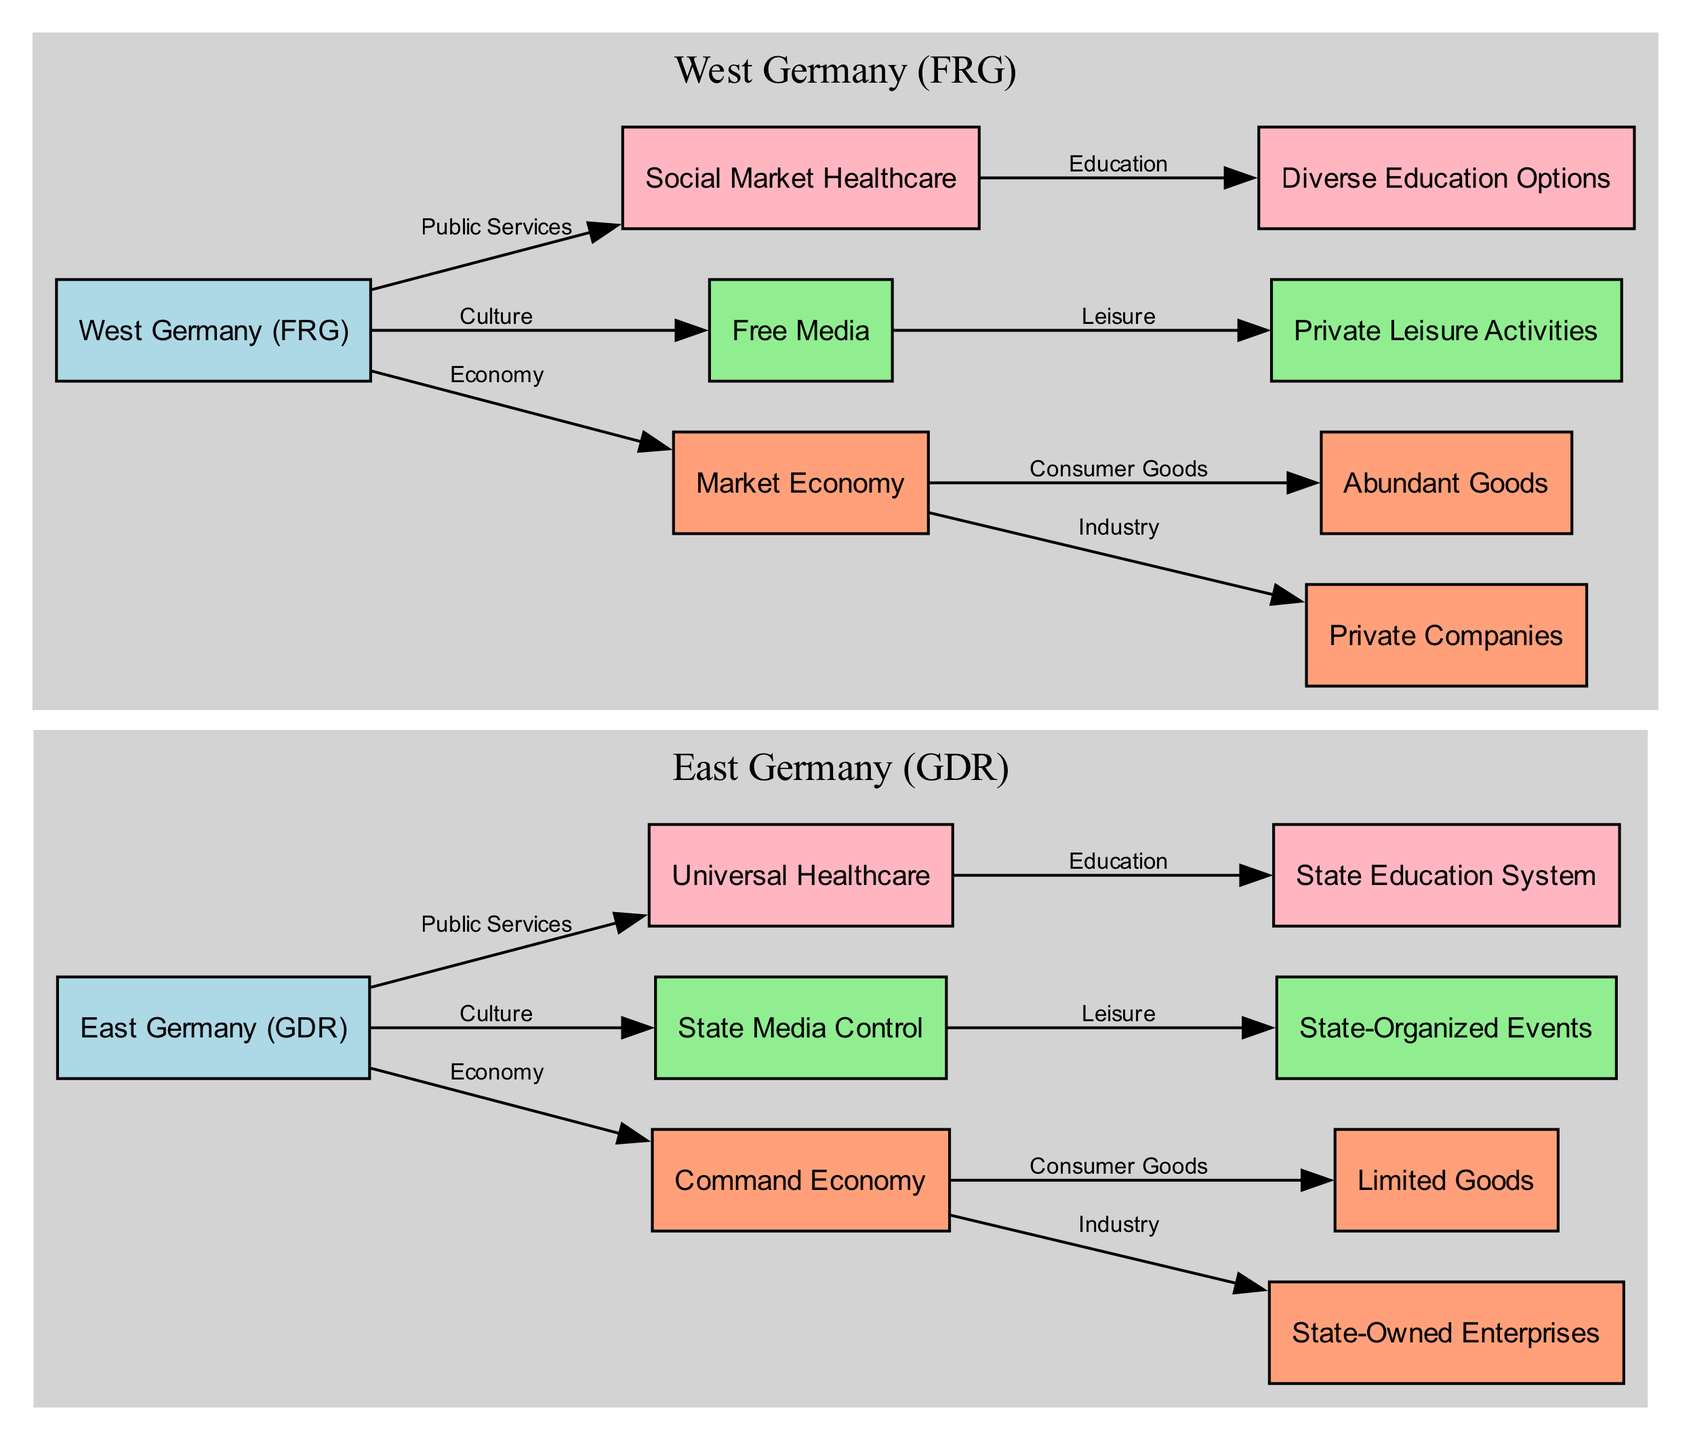What type of economy did East Germany have? The diagram shows that East Germany is connected to the node labeled "Command Economy". This indicates the type of economic system that existed in East Germany.
Answer: Command Economy What industry is associated with West Germany? The relationship from the "Market Economy" for West Germany leads to the node labeled "Private Companies", revealing the type of industry prevalent in West Germany.
Answer: Private Companies How many consumer goods types are shown in the diagram? The diagram details consumer goods in both East and West Germany, with two nodes: "Limited Goods" for East Germany and "Abundant Goods" for West Germany. Therefore, there are two consumer goods types depicted.
Answer: 2 Which public service is universal in East Germany? The connection from East Germany to the node "Universal Healthcare" indicates that this is the public service that is universally available in East Germany.
Answer: Universal Healthcare What is a significant cultural difference between East and West Germany? By examining the nodes for culture, East Germany connects to "State Media Control", while West Germany connects to "Free Media". This highlights a significant difference in cultural expression and media freedom between the two regions.
Answer: Media Control What type of education system was present in West Germany? The flow from West Germany to the corresponding node is labeled "Diverse Education Options", indicating the nature of the education system in West Germany.
Answer: Diverse Education Options Which leisure activities were organized by the state in East Germany? The diagram links East Germany's culture node to "State-Organized Events", indicating that these were the primary leisure activities provided in East Germany.
Answer: State-Organized Events Which node indicates the mostly state-controlled aspect of daily life in East Germany? The diagram reveals the node labeled "State Media Control" associated with East Germany, which indicates a major aspect of state influence in daily life, particularly in cultural practices.
Answer: State Media Control What is the relationship between the public service and education in East Germany? The edge clearly shows a relationship where "Universal Healthcare" connects to "State Education System", indicating that both are part of the public services provided in East Germany, reflecting a government system focusing on universal access.
Answer: Universal Healthcare to State Education System 